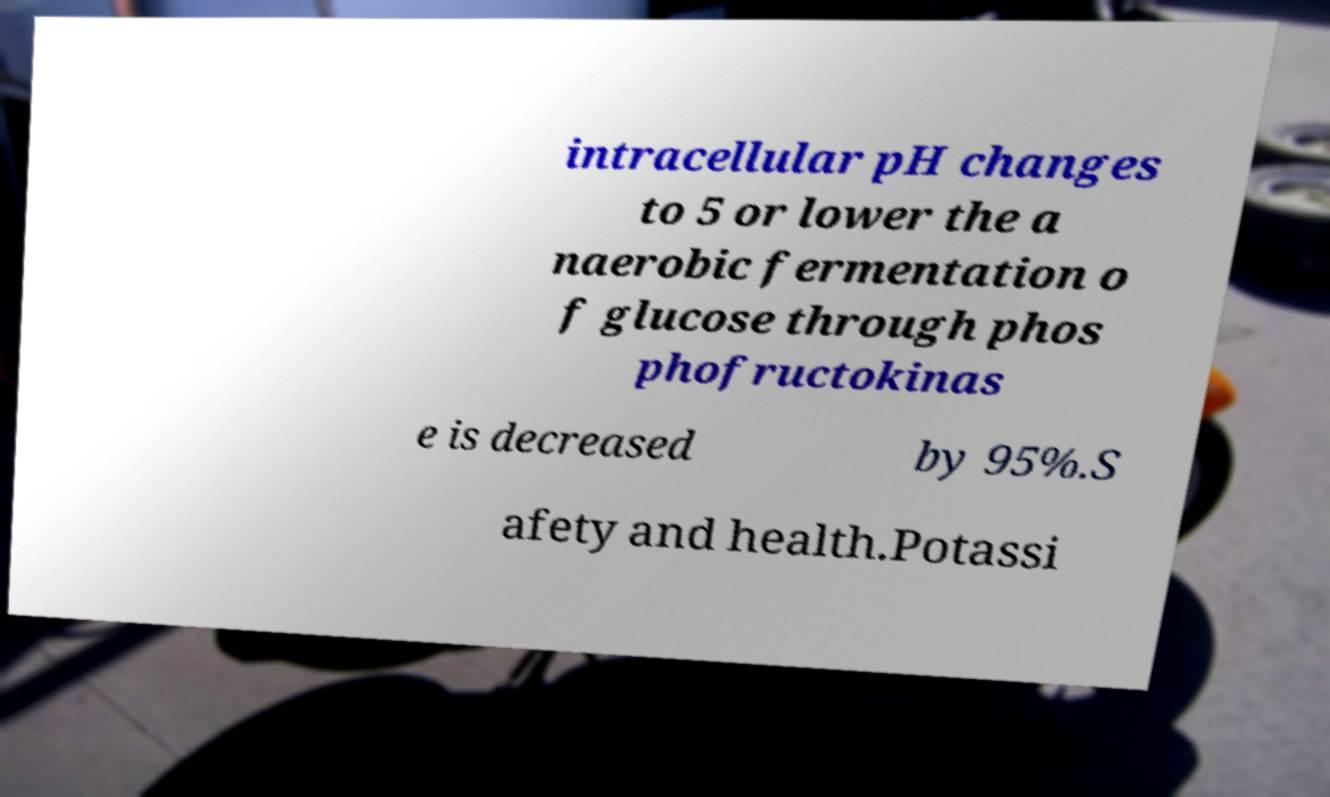Can you read and provide the text displayed in the image?This photo seems to have some interesting text. Can you extract and type it out for me? intracellular pH changes to 5 or lower the a naerobic fermentation o f glucose through phos phofructokinas e is decreased by 95%.S afety and health.Potassi 